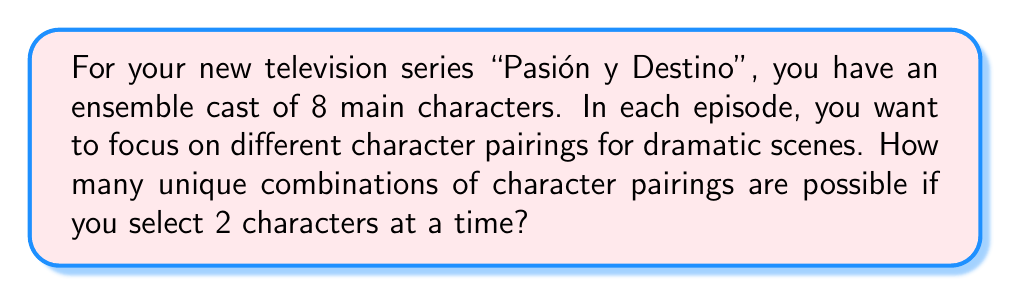Solve this math problem. Let's approach this step-by-step:

1) This is a combination problem. We are selecting 2 characters from a total of 8, where the order doesn't matter (pairing character A with character B is the same as pairing B with A).

2) The formula for combinations is:

   $$C(n,r) = \frac{n!}{r!(n-r)!}$$

   Where $n$ is the total number of items to choose from, and $r$ is the number of items being chosen.

3) In this case, $n = 8$ (total characters) and $r = 2$ (characters in each pairing).

4) Plugging these values into our formula:

   $$C(8,2) = \frac{8!}{2!(8-2)!} = \frac{8!}{2!(6)!}$$

5) Expand this:
   
   $$\frac{8 \cdot 7 \cdot 6!}{2 \cdot 1 \cdot 6!}$$

6) The 6! cancels out in the numerator and denominator:

   $$\frac{8 \cdot 7}{2 \cdot 1} = \frac{56}{2} = 28$$

Therefore, there are 28 unique character pairings possible.
Answer: 28 